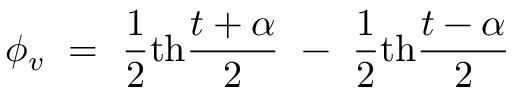<formula> <loc_0><loc_0><loc_500><loc_500>\phi _ { v } = { \frac { 1 } { 2 } } t h { \frac { t + \alpha } { 2 } } - { \frac { 1 } { 2 } } t h { \frac { t - \alpha } { 2 } }</formula> 